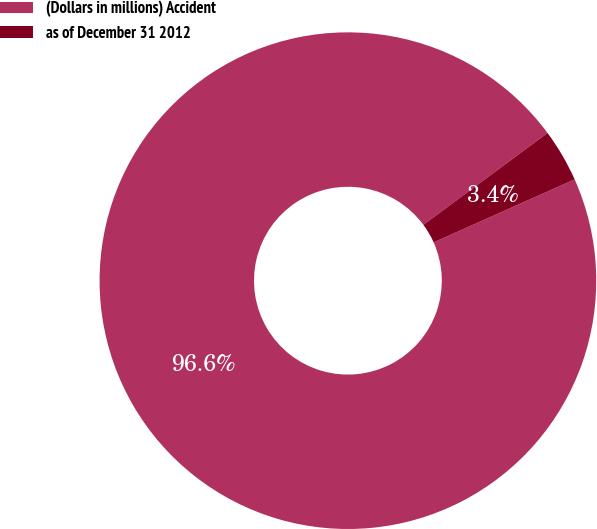Convert chart. <chart><loc_0><loc_0><loc_500><loc_500><pie_chart><fcel>(Dollars in millions) Accident<fcel>as of December 31 2012<nl><fcel>96.55%<fcel>3.45%<nl></chart> 